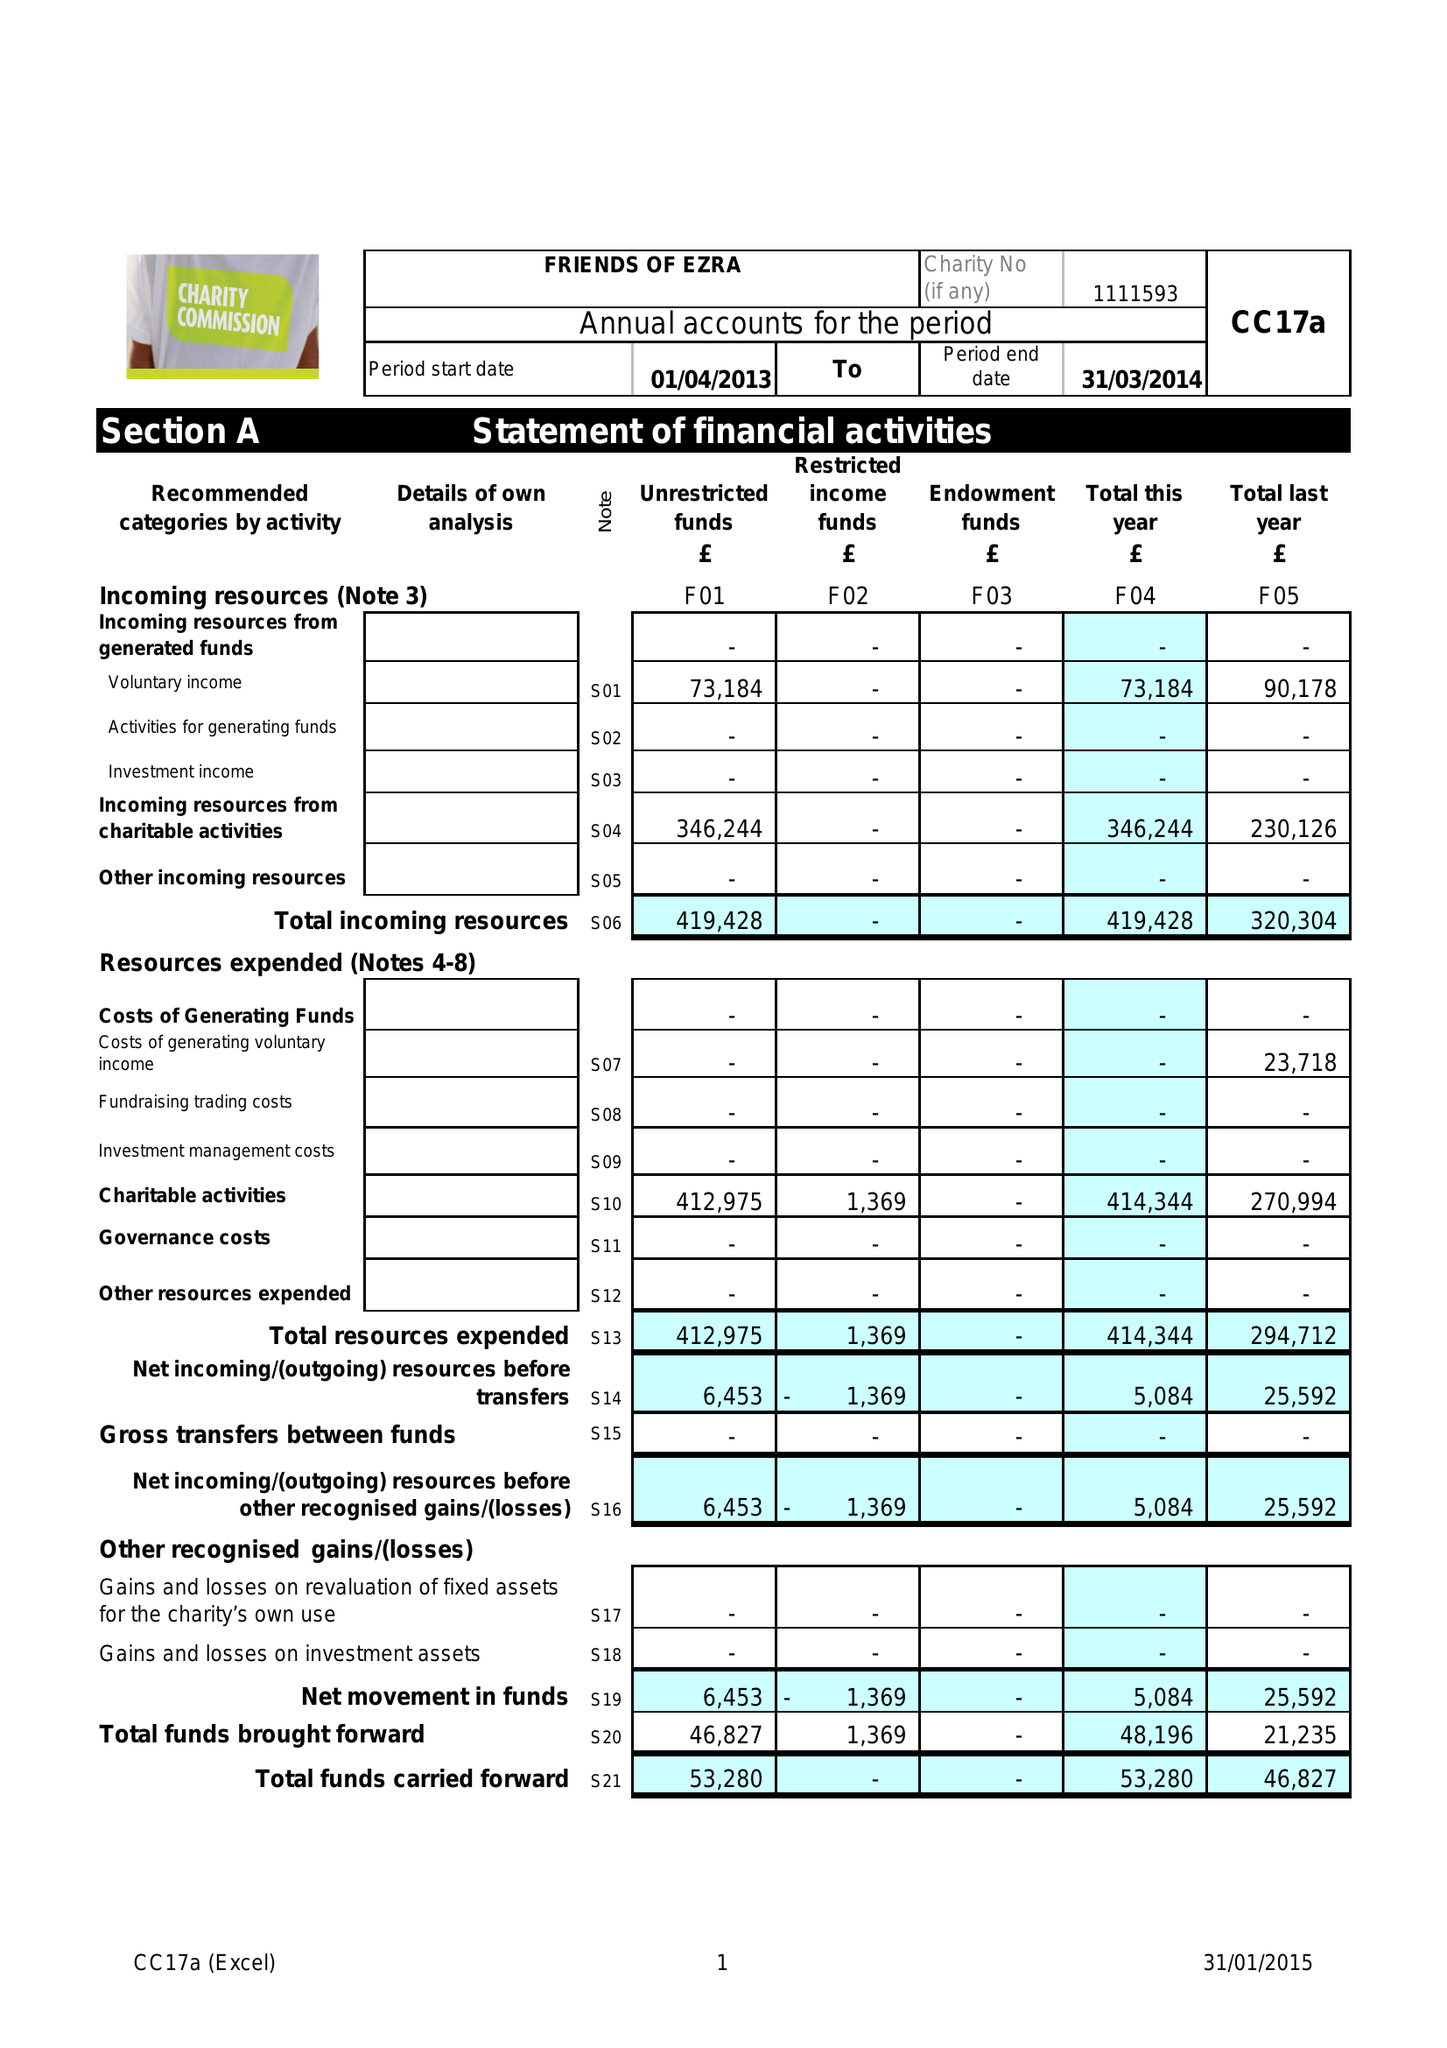What is the value for the spending_annually_in_british_pounds?
Answer the question using a single word or phrase. 414344.00 